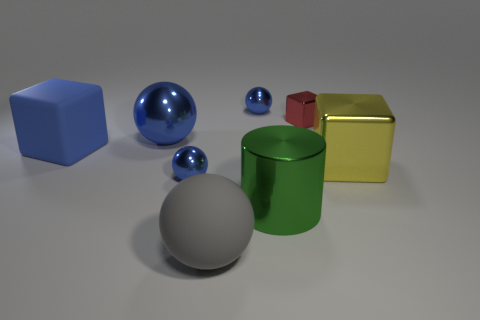Subtract all gray cubes. How many blue balls are left? 3 Subtract 1 spheres. How many spheres are left? 3 Add 1 big blue metal spheres. How many objects exist? 9 Subtract all green spheres. Subtract all red cubes. How many spheres are left? 4 Subtract all cylinders. How many objects are left? 7 Subtract 0 cyan balls. How many objects are left? 8 Subtract all large metal balls. Subtract all large gray rubber spheres. How many objects are left? 6 Add 3 large yellow things. How many large yellow things are left? 4 Add 1 large blocks. How many large blocks exist? 3 